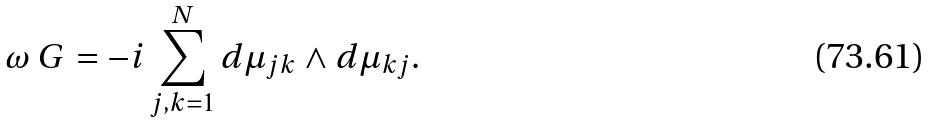<formula> <loc_0><loc_0><loc_500><loc_500>\omega _ { \ } G = - i \sum _ { j , k = 1 } ^ { N } d \mu _ { j k } \wedge d \mu _ { k j } .</formula> 